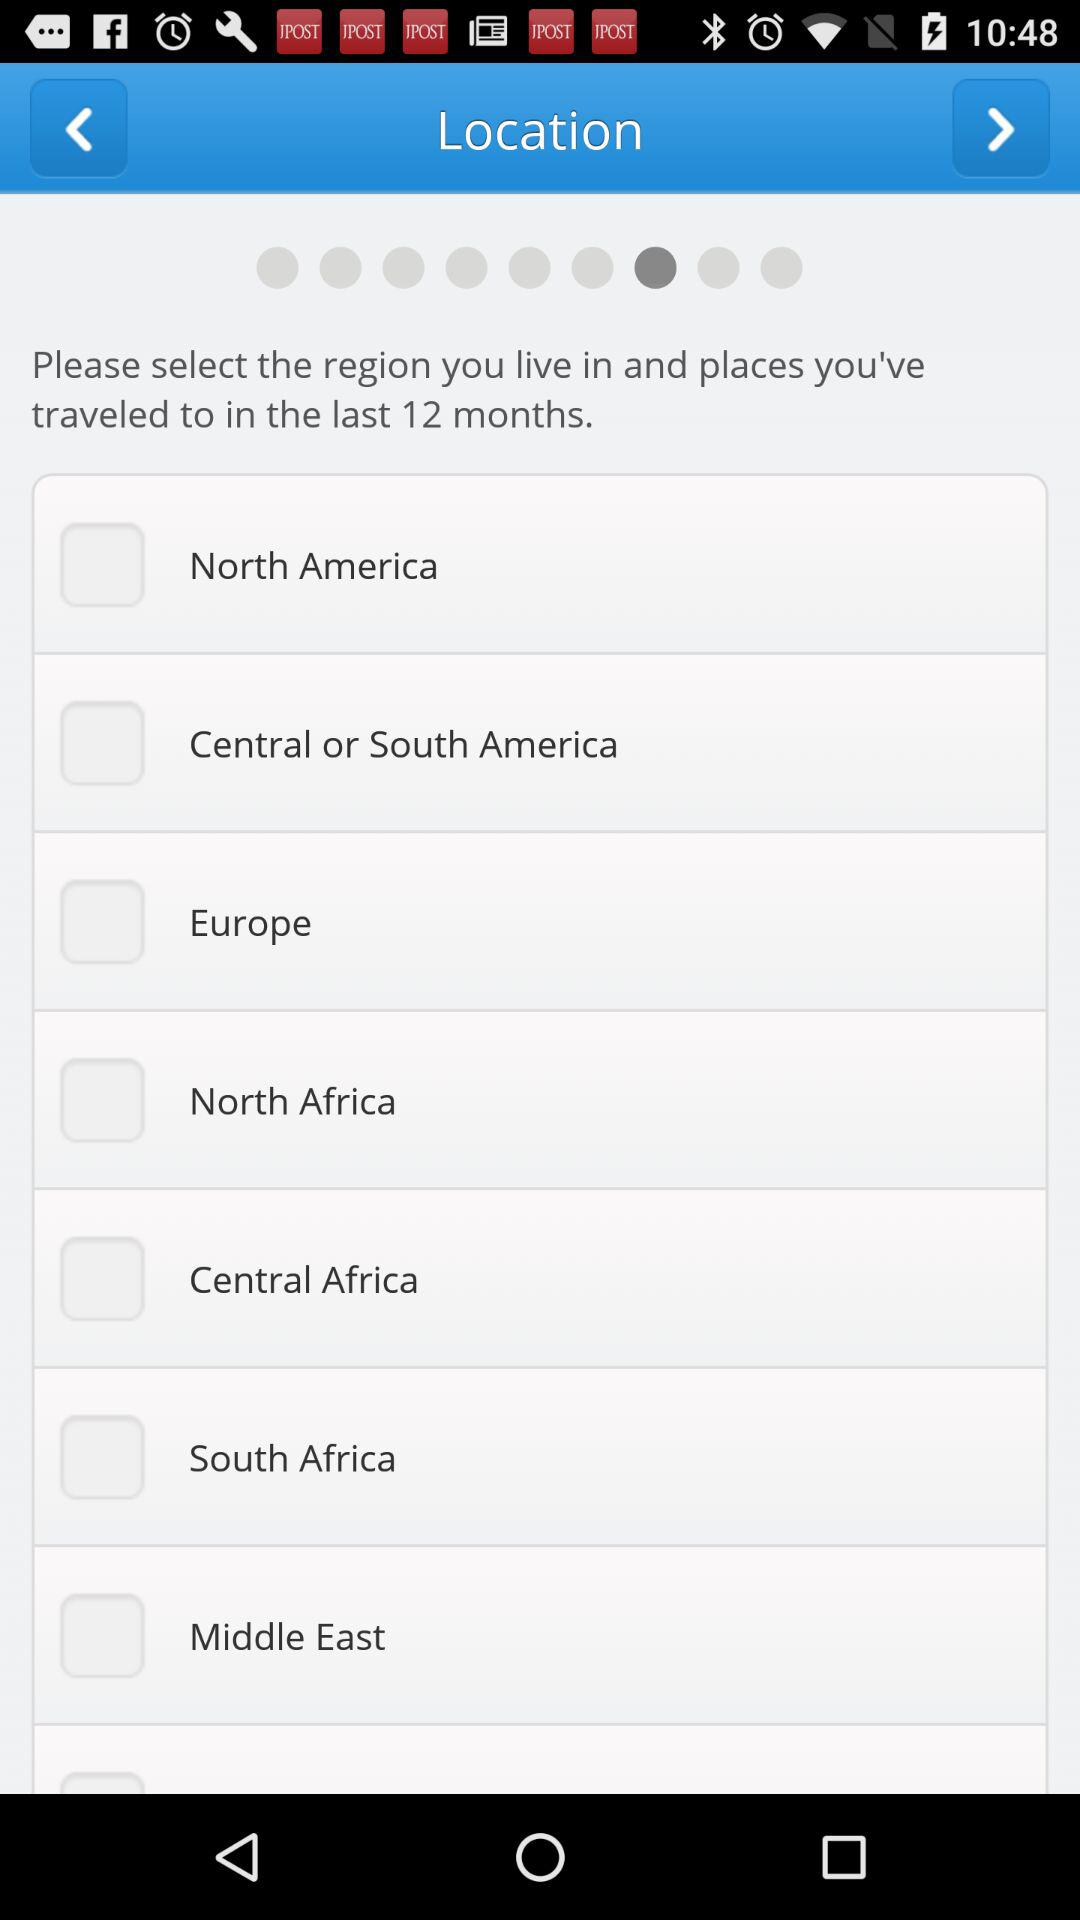What are the different available locations? The different available locations are North America, Central or South America, Europe, North Africa, Central Africa, South Africa and the Middle East. 